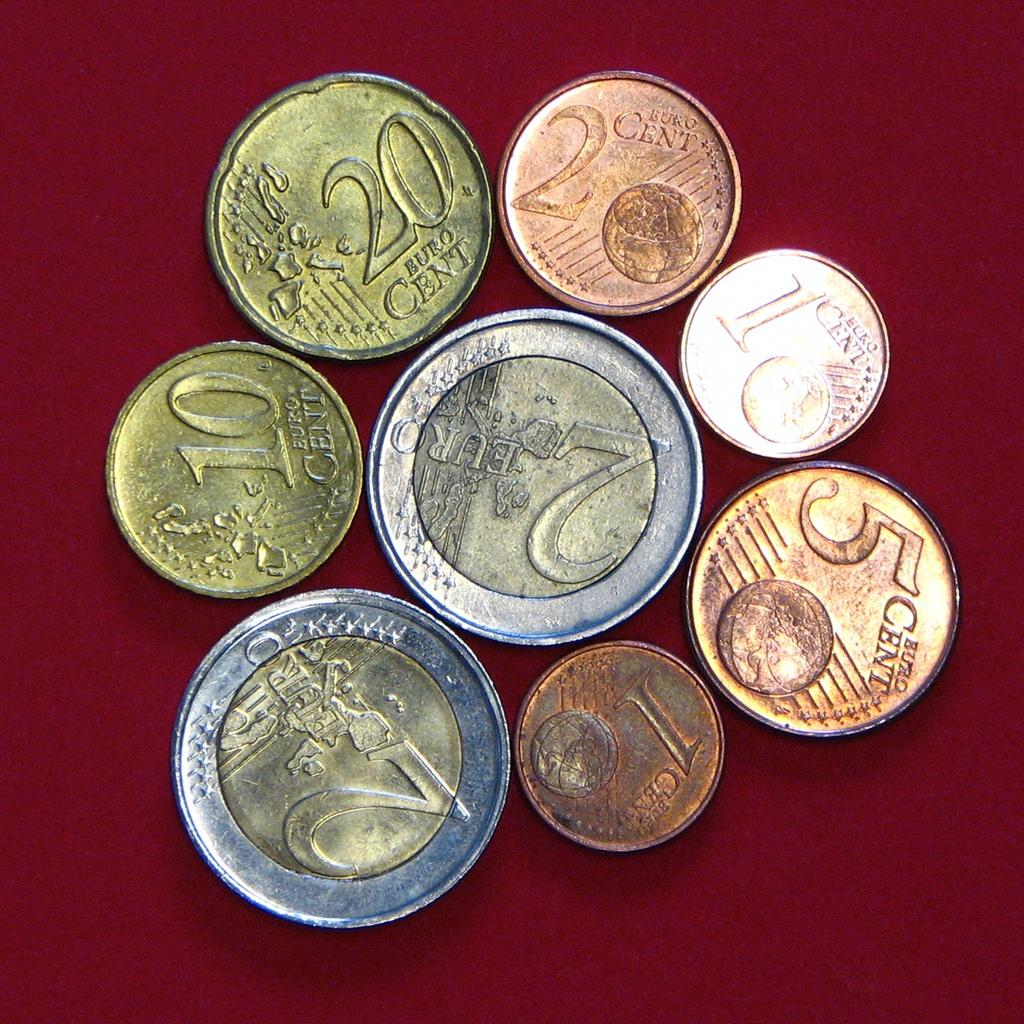Provide a one-sentence caption for the provided image. A range of Euro coins from 2 cents to 2 euros. 